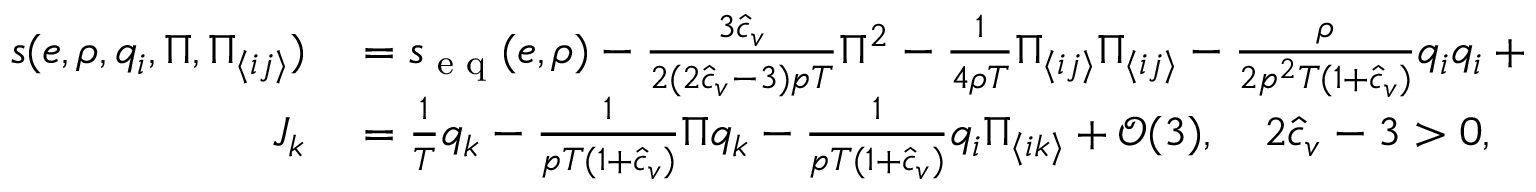Convert formula to latex. <formula><loc_0><loc_0><loc_500><loc_500>\begin{array} { r l } { s ( e , \rho , q _ { i } , \Pi , \Pi _ { \langle i j \rangle } ) } & = s _ { e q } ( e , \rho ) - \frac { 3 \hat { c } _ { v } } { 2 ( 2 \hat { c } _ { v } - 3 ) p T } \Pi ^ { 2 } - \frac { 1 } { 4 \rho T } \Pi _ { \langle i j \rangle } \Pi _ { \langle i j \rangle } - \frac { \rho } { 2 p ^ { 2 } T ( 1 + \hat { c } _ { v } ) } q _ { i } q _ { i } + \mathcal { O } ( 3 ) , } \\ { J _ { k } } & = \frac { 1 } { T } q _ { k } - \frac { 1 } { p T ( 1 + \hat { c } _ { v } ) } \Pi q _ { k } - \frac { 1 } { p T ( 1 + \hat { c } _ { v } ) } q _ { i } \Pi _ { \langle i k \rangle } + \mathcal { O } ( 3 ) , \quad 2 \hat { c } _ { v } - 3 > 0 , } \end{array}</formula> 